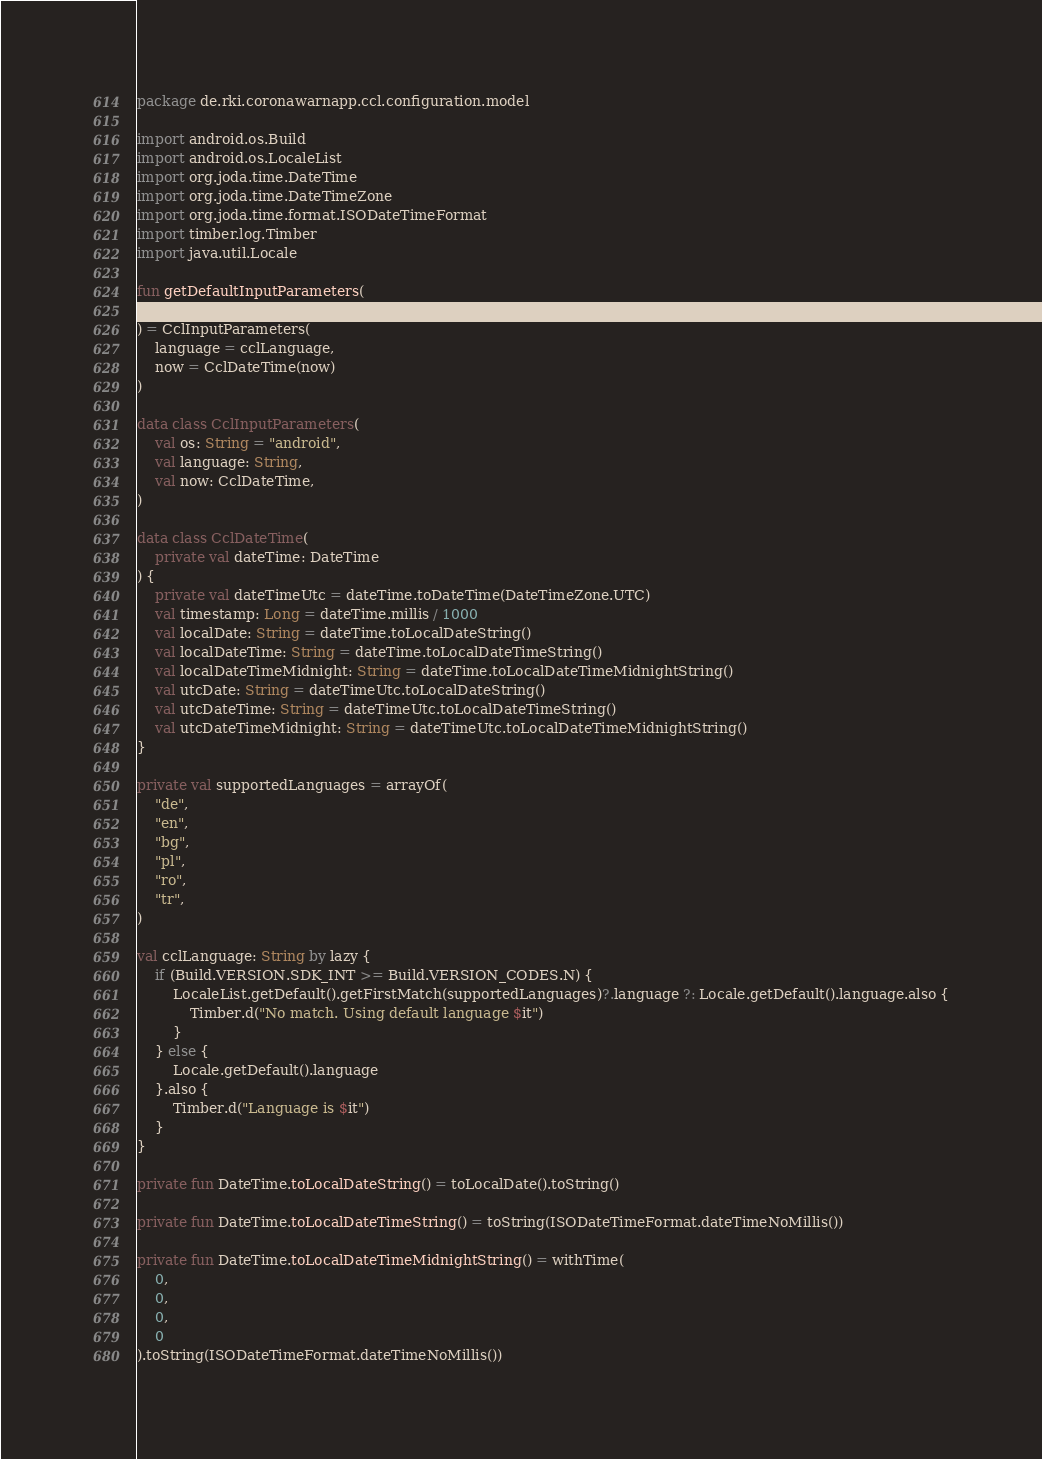Convert code to text. <code><loc_0><loc_0><loc_500><loc_500><_Kotlin_>package de.rki.coronawarnapp.ccl.configuration.model

import android.os.Build
import android.os.LocaleList
import org.joda.time.DateTime
import org.joda.time.DateTimeZone
import org.joda.time.format.ISODateTimeFormat
import timber.log.Timber
import java.util.Locale

fun getDefaultInputParameters(
    now: DateTime
) = CclInputParameters(
    language = cclLanguage,
    now = CclDateTime(now)
)

data class CclInputParameters(
    val os: String = "android",
    val language: String,
    val now: CclDateTime,
)

data class CclDateTime(
    private val dateTime: DateTime
) {
    private val dateTimeUtc = dateTime.toDateTime(DateTimeZone.UTC)
    val timestamp: Long = dateTime.millis / 1000
    val localDate: String = dateTime.toLocalDateString()
    val localDateTime: String = dateTime.toLocalDateTimeString()
    val localDateTimeMidnight: String = dateTime.toLocalDateTimeMidnightString()
    val utcDate: String = dateTimeUtc.toLocalDateString()
    val utcDateTime: String = dateTimeUtc.toLocalDateTimeString()
    val utcDateTimeMidnight: String = dateTimeUtc.toLocalDateTimeMidnightString()
}

private val supportedLanguages = arrayOf(
    "de",
    "en",
    "bg",
    "pl",
    "ro",
    "tr",
)

val cclLanguage: String by lazy {
    if (Build.VERSION.SDK_INT >= Build.VERSION_CODES.N) {
        LocaleList.getDefault().getFirstMatch(supportedLanguages)?.language ?: Locale.getDefault().language.also {
            Timber.d("No match. Using default language $it")
        }
    } else {
        Locale.getDefault().language
    }.also {
        Timber.d("Language is $it")
    }
}

private fun DateTime.toLocalDateString() = toLocalDate().toString()

private fun DateTime.toLocalDateTimeString() = toString(ISODateTimeFormat.dateTimeNoMillis())

private fun DateTime.toLocalDateTimeMidnightString() = withTime(
    0,
    0,
    0,
    0
).toString(ISODateTimeFormat.dateTimeNoMillis())
</code> 